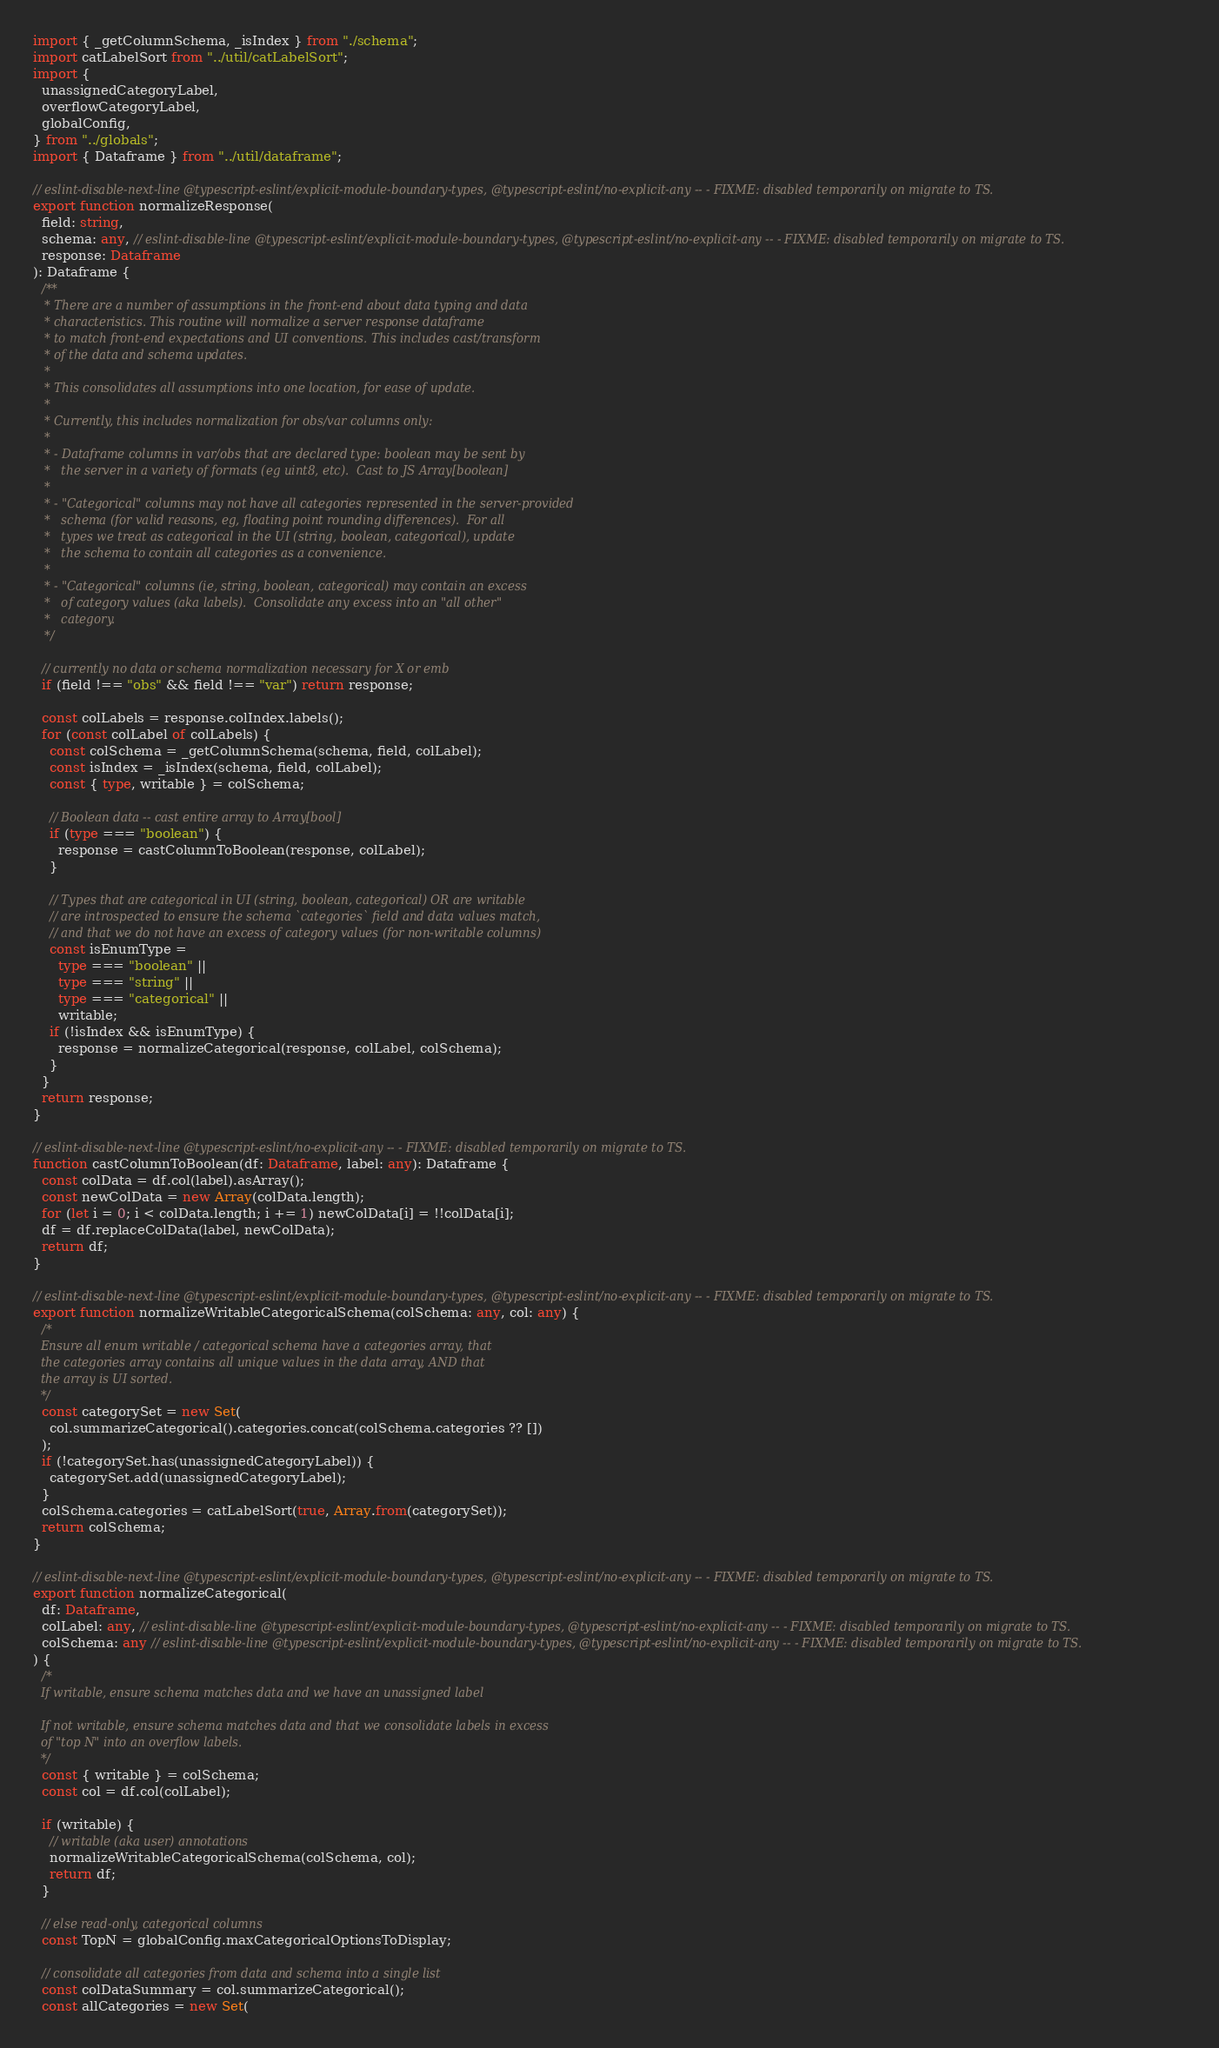<code> <loc_0><loc_0><loc_500><loc_500><_TypeScript_>import { _getColumnSchema, _isIndex } from "./schema";
import catLabelSort from "../util/catLabelSort";
import {
  unassignedCategoryLabel,
  overflowCategoryLabel,
  globalConfig,
} from "../globals";
import { Dataframe } from "../util/dataframe";

// eslint-disable-next-line @typescript-eslint/explicit-module-boundary-types, @typescript-eslint/no-explicit-any -- - FIXME: disabled temporarily on migrate to TS.
export function normalizeResponse(
  field: string,
  schema: any, // eslint-disable-line @typescript-eslint/explicit-module-boundary-types, @typescript-eslint/no-explicit-any -- - FIXME: disabled temporarily on migrate to TS.
  response: Dataframe
): Dataframe {
  /**
   * There are a number of assumptions in the front-end about data typing and data
   * characteristics. This routine will normalize a server response dataframe
   * to match front-end expectations and UI conventions. This includes cast/transform
   * of the data and schema updates.
   *
   * This consolidates all assumptions into one location, for ease of update.
   *
   * Currently, this includes normalization for obs/var columns only:
   *
   * - Dataframe columns in var/obs that are declared type: boolean may be sent by
   *   the server in a variety of formats (eg uint8, etc).  Cast to JS Array[boolean]
   *
   * - "Categorical" columns may not have all categories represented in the server-provided
   *   schema (for valid reasons, eg, floating point rounding differences).  For all
   *   types we treat as categorical in the UI (string, boolean, categorical), update
   *   the schema to contain all categories as a convenience.
   *
   * - "Categorical" columns (ie, string, boolean, categorical) may contain an excess
   *   of category values (aka labels).  Consolidate any excess into an "all other"
   *   category.
   */

  // currently no data or schema normalization necessary for X or emb
  if (field !== "obs" && field !== "var") return response;

  const colLabels = response.colIndex.labels();
  for (const colLabel of colLabels) {
    const colSchema = _getColumnSchema(schema, field, colLabel);
    const isIndex = _isIndex(schema, field, colLabel);
    const { type, writable } = colSchema;

    // Boolean data -- cast entire array to Array[bool]
    if (type === "boolean") {
      response = castColumnToBoolean(response, colLabel);
    }

    // Types that are categorical in UI (string, boolean, categorical) OR are writable
    // are introspected to ensure the schema `categories` field and data values match,
    // and that we do not have an excess of category values (for non-writable columns)
    const isEnumType =
      type === "boolean" ||
      type === "string" ||
      type === "categorical" ||
      writable;
    if (!isIndex && isEnumType) {
      response = normalizeCategorical(response, colLabel, colSchema);
    }
  }
  return response;
}

// eslint-disable-next-line @typescript-eslint/no-explicit-any -- - FIXME: disabled temporarily on migrate to TS.
function castColumnToBoolean(df: Dataframe, label: any): Dataframe {
  const colData = df.col(label).asArray();
  const newColData = new Array(colData.length);
  for (let i = 0; i < colData.length; i += 1) newColData[i] = !!colData[i];
  df = df.replaceColData(label, newColData);
  return df;
}

// eslint-disable-next-line @typescript-eslint/explicit-module-boundary-types, @typescript-eslint/no-explicit-any -- - FIXME: disabled temporarily on migrate to TS.
export function normalizeWritableCategoricalSchema(colSchema: any, col: any) {
  /*
  Ensure all enum writable / categorical schema have a categories array, that
  the categories array contains all unique values in the data array, AND that 
  the array is UI sorted.
  */
  const categorySet = new Set(
    col.summarizeCategorical().categories.concat(colSchema.categories ?? [])
  );
  if (!categorySet.has(unassignedCategoryLabel)) {
    categorySet.add(unassignedCategoryLabel);
  }
  colSchema.categories = catLabelSort(true, Array.from(categorySet));
  return colSchema;
}

// eslint-disable-next-line @typescript-eslint/explicit-module-boundary-types, @typescript-eslint/no-explicit-any -- - FIXME: disabled temporarily on migrate to TS.
export function normalizeCategorical(
  df: Dataframe,
  colLabel: any, // eslint-disable-line @typescript-eslint/explicit-module-boundary-types, @typescript-eslint/no-explicit-any -- - FIXME: disabled temporarily on migrate to TS.
  colSchema: any // eslint-disable-line @typescript-eslint/explicit-module-boundary-types, @typescript-eslint/no-explicit-any -- - FIXME: disabled temporarily on migrate to TS.
) {
  /*
  If writable, ensure schema matches data and we have an unassigned label

  If not writable, ensure schema matches data and that we consolidate labels in excess
  of "top N" into an overflow labels.
  */
  const { writable } = colSchema;
  const col = df.col(colLabel);

  if (writable) {
    // writable (aka user) annotations
    normalizeWritableCategoricalSchema(colSchema, col);
    return df;
  }

  // else read-only, categorical columns
  const TopN = globalConfig.maxCategoricalOptionsToDisplay;

  // consolidate all categories from data and schema into a single list
  const colDataSummary = col.summarizeCategorical();
  const allCategories = new Set(</code> 